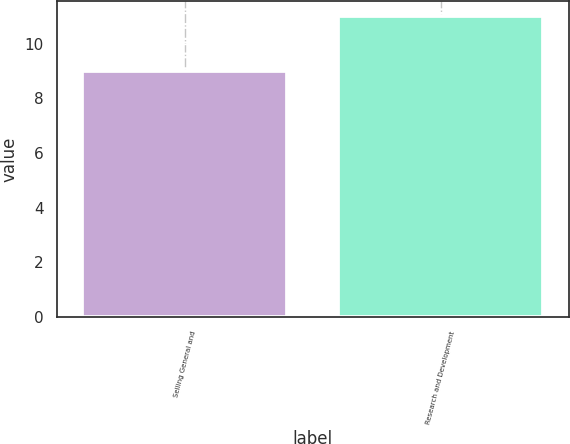Convert chart. <chart><loc_0><loc_0><loc_500><loc_500><bar_chart><fcel>Selling General and<fcel>Research and Development<nl><fcel>9<fcel>11<nl></chart> 